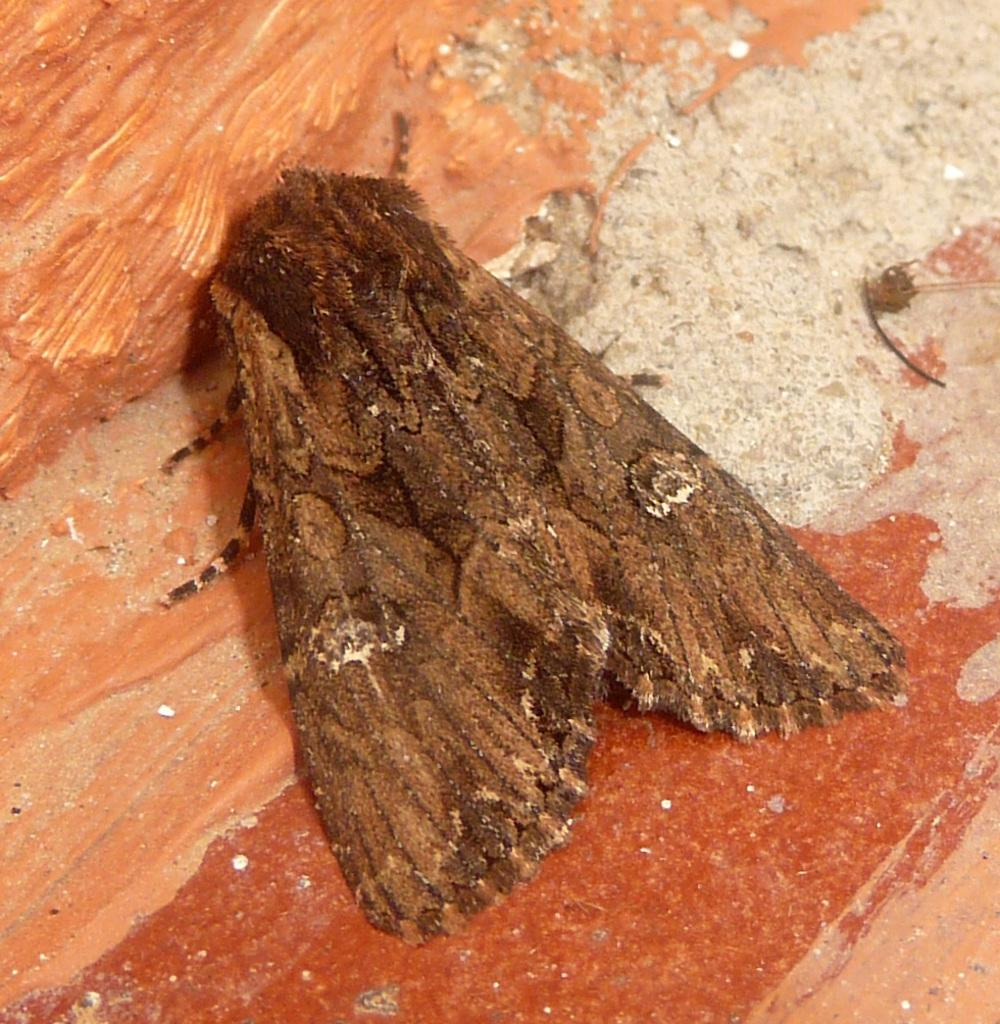What type of insect is in the picture? There is a brown house moth insect in the picture. What is the insect resting on? The insect is on a wooden block. What type of cake is visible in the jar in the image? There is no cake or jar present in the image; it only features a brown house moth insect on a wooden block. What industry is depicted in the image? The image does not depict any industry; it is a close-up of a brown house moth insect on a wooden block. 